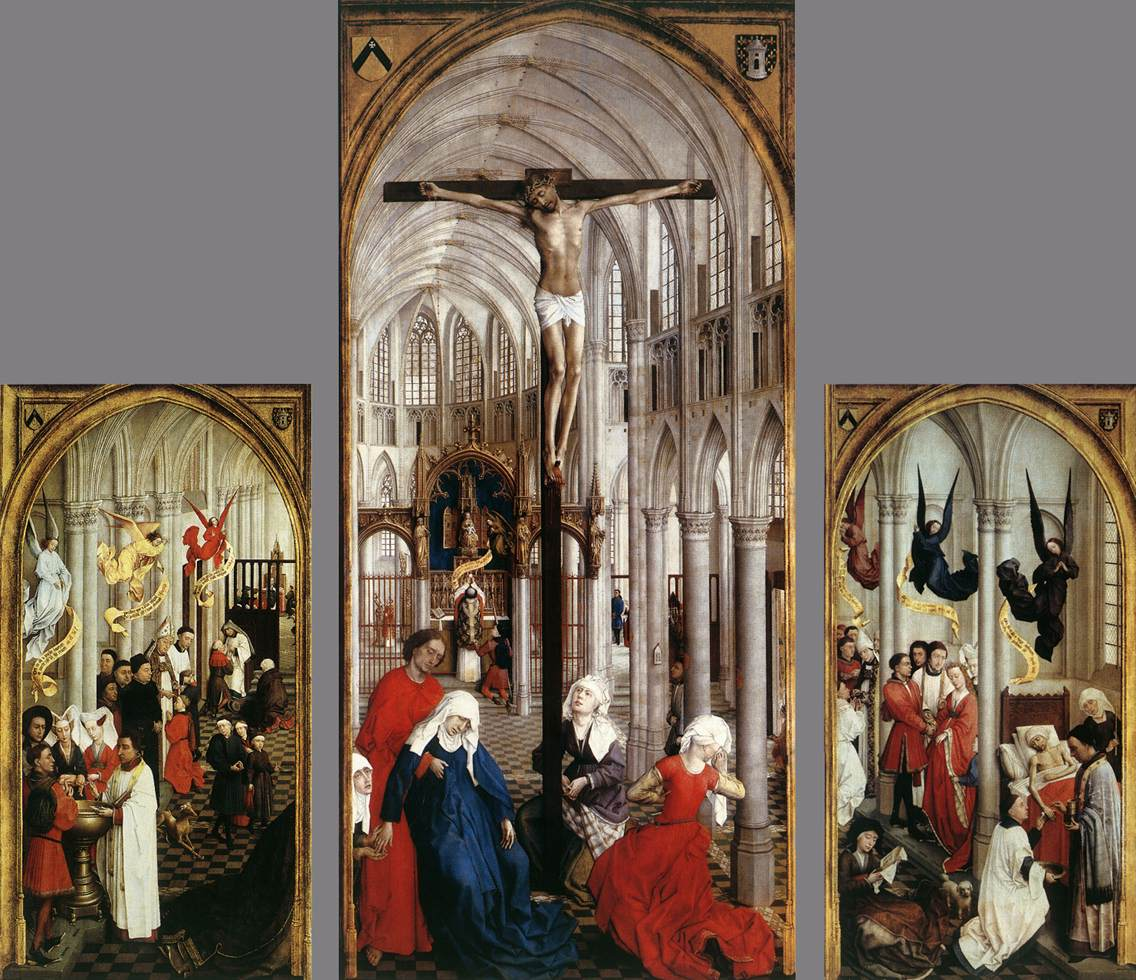What does the left panel tell us about the cultural or religious context of the period? The left panel is evocative of the religious reverence and hierarchical structure of the society during the Northern Renaissance. The presence of various saints, all attentively participating in a religious ceremony, underscores the era's deep religiosity. The detailed depiction of garments and spatial organization also reflects the period's artistic focus on realism and depth, often used to convey spiritual and moral messages effectively. 